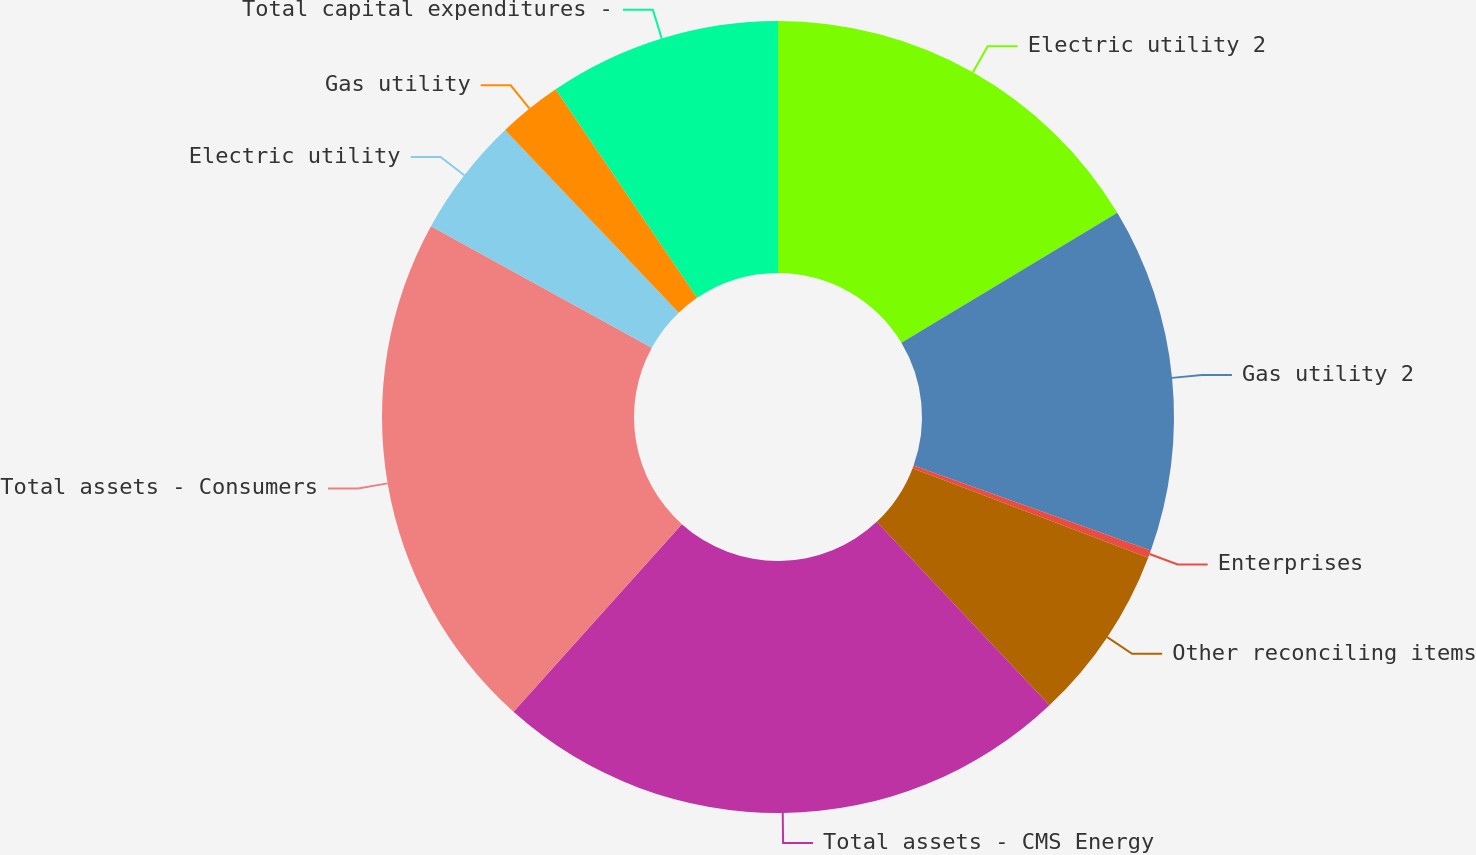Convert chart to OTSL. <chart><loc_0><loc_0><loc_500><loc_500><pie_chart><fcel>Electric utility 2<fcel>Gas utility 2<fcel>Enterprises<fcel>Other reconciling items<fcel>Total assets - CMS Energy<fcel>Total assets - Consumers<fcel>Electric utility<fcel>Gas utility<fcel>Total capital expenditures -<nl><fcel>16.38%<fcel>14.09%<fcel>0.31%<fcel>7.2%<fcel>23.66%<fcel>21.36%<fcel>4.9%<fcel>2.61%<fcel>9.49%<nl></chart> 